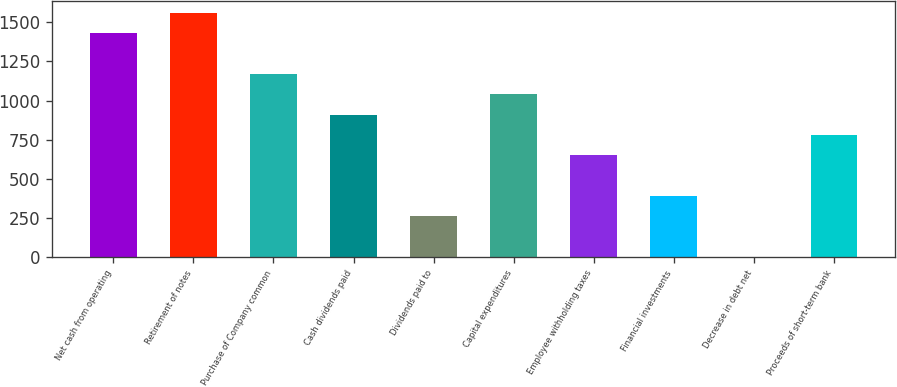Convert chart to OTSL. <chart><loc_0><loc_0><loc_500><loc_500><bar_chart><fcel>Net cash from operating<fcel>Retirement of notes<fcel>Purchase of Company common<fcel>Cash dividends paid<fcel>Dividends paid to<fcel>Capital expenditures<fcel>Employee withholding taxes<fcel>Financial investments<fcel>Decrease in debt net<fcel>Proceeds of short-term bank<nl><fcel>1429.9<fcel>1559.8<fcel>1170.1<fcel>910.3<fcel>260.8<fcel>1040.2<fcel>650.5<fcel>390.7<fcel>1<fcel>780.4<nl></chart> 